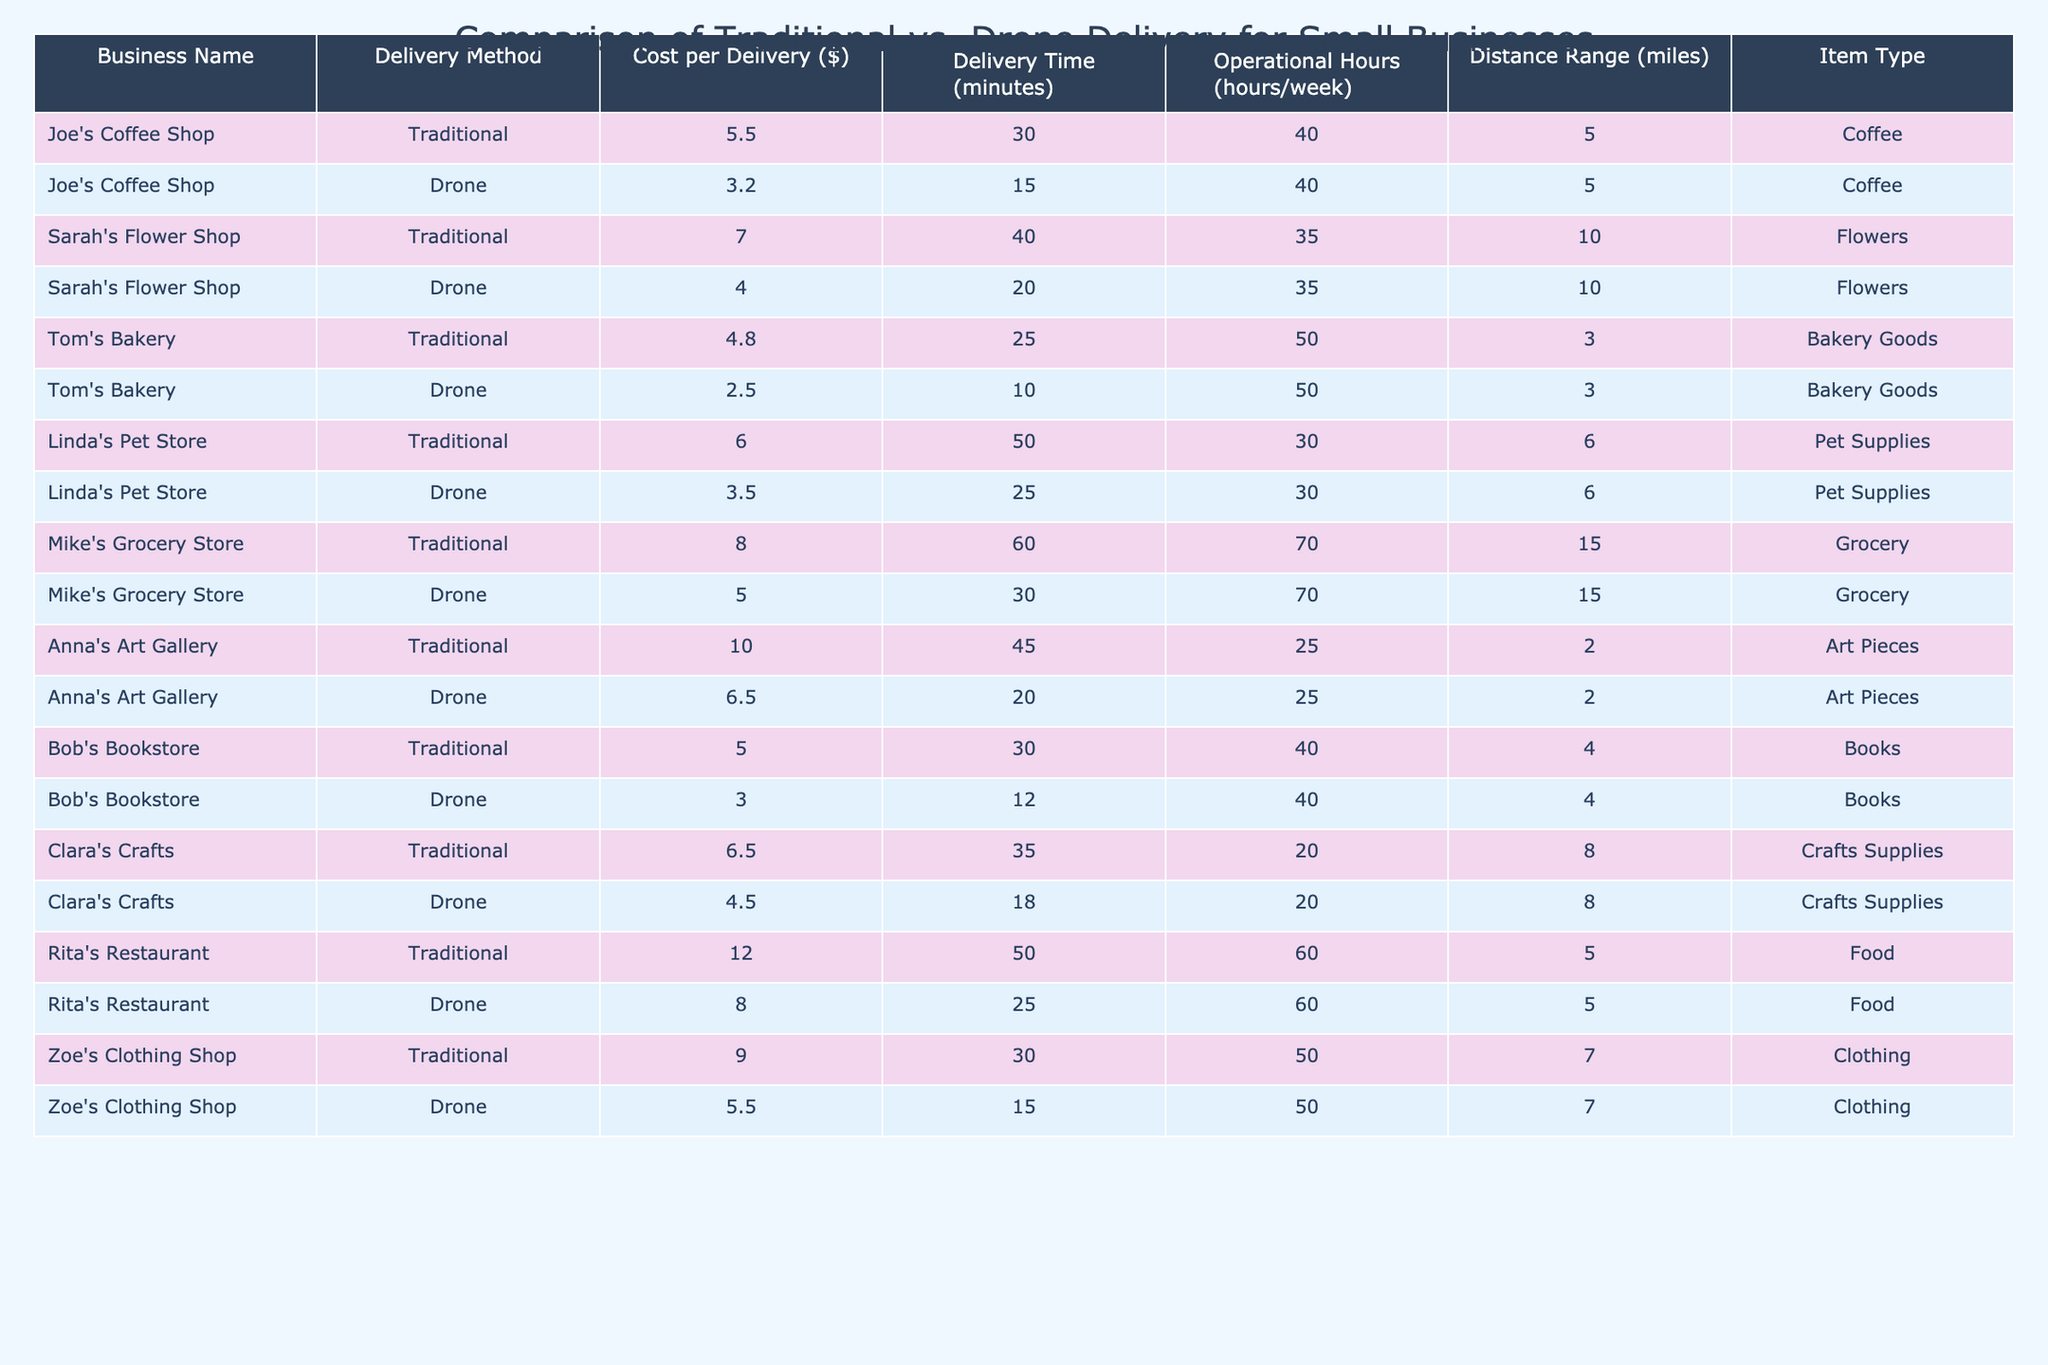What is the cost per delivery for Joe's Coffee Shop using traditional methods? The table shows that Joe's Coffee Shop has a cost of $5.50 for traditional delivery.
Answer: $5.50 What is the delivery time for drone delivery at Sarah's Flower Shop? The table indicates that the delivery time for drone delivery at Sarah's Flower Shop is 20 minutes.
Answer: 20 minutes Which delivery method is cheaper for Tom's Bakery? By comparing the costs, $4.80 for traditional delivery and $2.50 for drone delivery, we can see that drone delivery is cheaper.
Answer: Drone delivery How much more does it cost to deliver groceries using traditional methods compared to drone delivery at Mike's Grocery Store? The traditional delivery cost is $8.00 and the drone delivery cost is $5.00. The difference is $8.00 - $5.00 = $3.00.
Answer: $3.00 Which small business has the highest cost for traditional delivery? Looking through the table, Anna's Art Gallery has a cost of $10.00 for traditional delivery, which is the highest among the businesses listed.
Answer: Anna's Art Gallery Is the delivery time shorter for drone delivery compared to traditional delivery at Linda's Pet Store? The table shows that traditional delivery takes 50 minutes while drone delivery takes 25 minutes. Yes, the drone delivery time is shorter.
Answer: Yes What are the average costs for traditional and drone delivery methods across all businesses? Summing up the traditional costs ($5.50 + $7.00 + $4.80 + $6.00 + $8.00 + $10.00 + $5.00 + $6.50 + $12.00 + $9.00) gives $64.80. There are 10 entries, so the average is $64.80/10 = $6.48. For drone delivery, the sum is ($3.20 + $4.00 + $2.50 + $3.50 + $5.00 + $6.50 + $3.00 + $4.50 + $8.00 + $5.50) = $45.70, so the average is $45.70/10 = $4.57.
Answer: Traditional: $6.48; Drone: $4.57 Which business has the largest delivery range for drone delivery? Analyzing the distance range for drone delivery, Mike's Grocery Store and Sarah's Flower Shop both have a range of 15 miles and 10 miles respectively, meaning Mike's Grocery Store has the largest range at 15 miles.
Answer: Mike's Grocery Store Are there more businesses that have a lower cost for drone delivery compared to traditional delivery? Counting in the table, there are 8 out of 10 businesses that have lower costs for drone delivery compared to traditional delivery.
Answer: Yes What is the delivery cost difference between Rita's Restaurant using traditional and drone delivery? Traditional delivery costs $12.00, and drone delivery costs $8.00. The difference is $12.00 - $8.00 = $4.00.
Answer: $4.00 Does Zoe's Clothing Shop have a shorter delivery time using drone delivery compared to traditional delivery? Traditional delivery at Zoe's Clothing Shop takes 30 minutes, while drone delivery takes 15 minutes, showing that drone delivery time is shorter.
Answer: Yes 